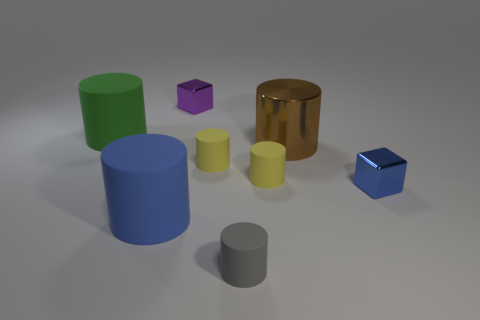Are the large cylinder to the right of the small purple thing and the small purple thing to the left of the tiny blue block made of the same material?
Provide a short and direct response. Yes. The small gray thing is what shape?
Give a very brief answer. Cylinder. Is the number of large blue objects that are to the right of the tiny gray object the same as the number of tiny metallic cubes?
Your answer should be compact. No. Is there another big cylinder that has the same material as the large blue cylinder?
Give a very brief answer. Yes. Do the small shiny thing that is in front of the purple cube and the thing that is in front of the blue cylinder have the same shape?
Ensure brevity in your answer.  No. Is there a small red cylinder?
Provide a short and direct response. No. There is a block that is the same size as the blue shiny object; what is its color?
Keep it short and to the point. Purple. What number of tiny blue objects are the same shape as the purple thing?
Make the answer very short. 1. Is the material of the big green cylinder behind the tiny gray matte object the same as the tiny blue block?
Offer a very short reply. No. What number of balls are either purple things or yellow objects?
Your answer should be compact. 0. 